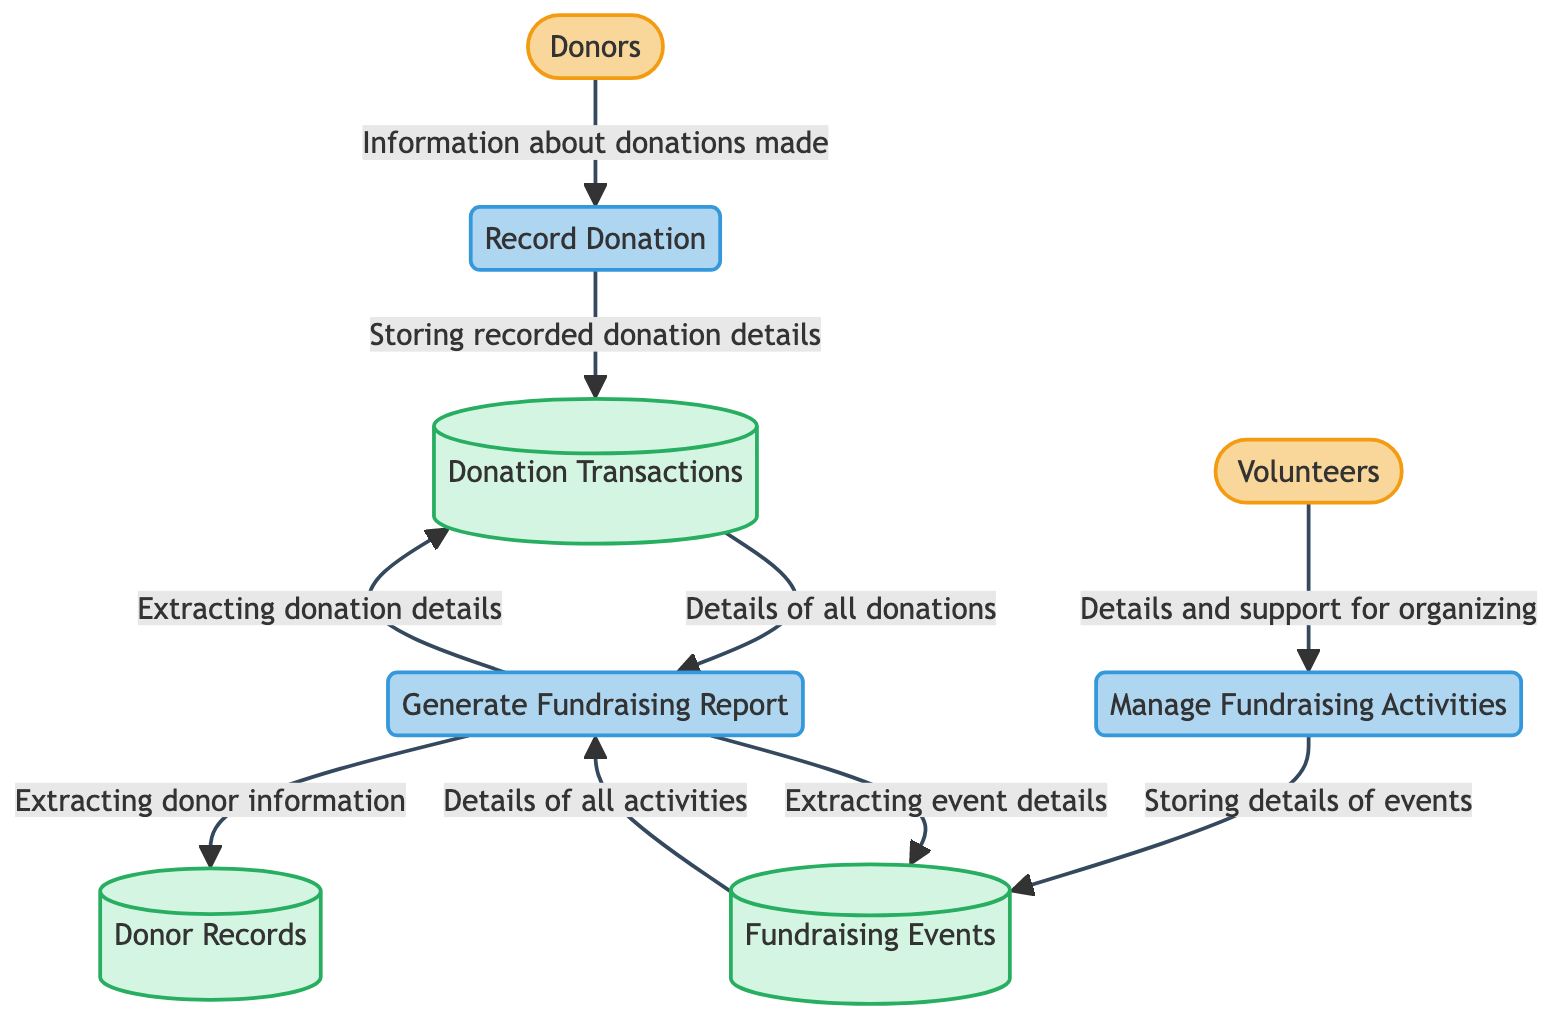What are the two external entities in the diagram? The diagram shows two external entities: Donors and Volunteers. These are the sources of information flowing into the system.
Answer: Donors, Volunteers How many data stores are present in the diagram? The diagram includes three data stores: Donor Records, Donation Transactions, and Fundraising Events. You can count them from the data store section of the diagram.
Answer: 3 What information do donors provide? Donors provide information about donations made, which is indicated by the data flow from Donors to Record Donation.
Answer: Information about donations made Which process is responsible for managing fundraising activities? The process responsible for managing fundraising activities is labeled Manage Fundraising Activities, as shown in the diagram.
Answer: Manage Fundraising Activities What is extracted from Donation Transactions for reporting? The Generate Fundraising Report process extracts details of all donations made from the Donation Transactions data store, as indicated by the data flow.
Answer: Details of all donations Which external entity supports Organizing Fundraising Activities? The Volunteers external entity provides details and support for organizing fundraising activities, flowing into the Manage Fundraising Activities process.
Answer: Volunteers How many processes are there in the diagram? The diagram comprises three processes: Record Donation, Generate Fundraising Report, and Manage Fundraising Activities, which can be counted from the process section.
Answer: 3 What data flow takes place between Manage Fundraising Activities and Fundraising Events? The data flow from Manage Fundraising Activities to Fundraising Events is about storing details of fundraising events, as illustrated in the diagram.
Answer: Storing details of events Which data store provides donor information for generating reports? The Donor Records data store provides donor information for reporting, as indicated by the data flow from Generate Fundraising Report to Donor Records.
Answer: Donor Records 